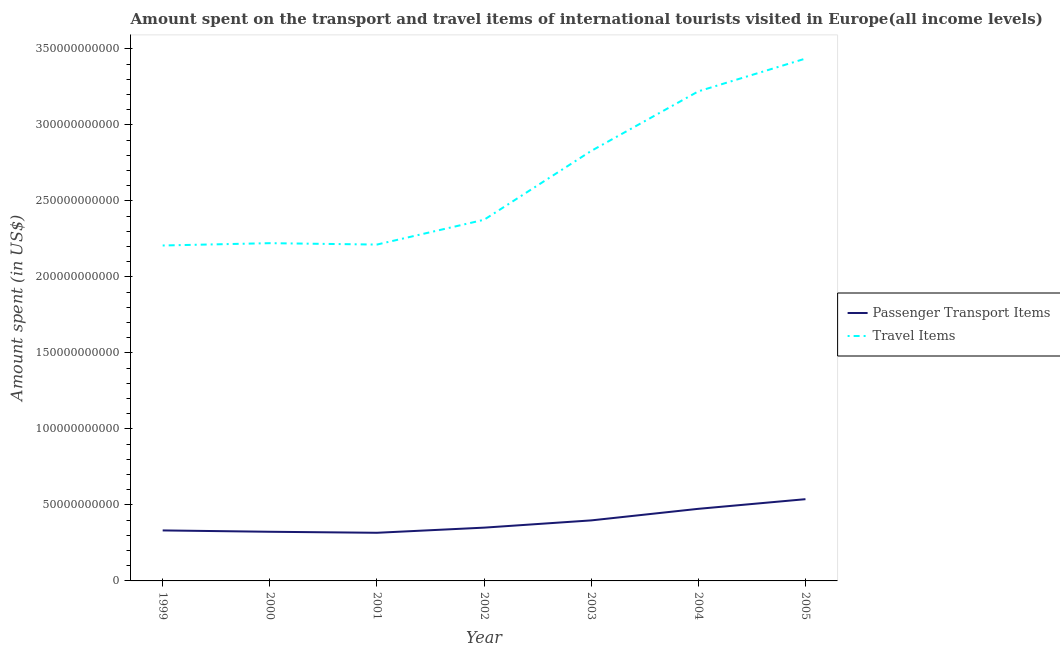Does the line corresponding to amount spent on passenger transport items intersect with the line corresponding to amount spent in travel items?
Offer a very short reply. No. What is the amount spent in travel items in 2000?
Ensure brevity in your answer.  2.22e+11. Across all years, what is the maximum amount spent in travel items?
Give a very brief answer. 3.44e+11. Across all years, what is the minimum amount spent in travel items?
Your answer should be very brief. 2.21e+11. In which year was the amount spent on passenger transport items maximum?
Your response must be concise. 2005. In which year was the amount spent on passenger transport items minimum?
Provide a short and direct response. 2001. What is the total amount spent on passenger transport items in the graph?
Make the answer very short. 2.73e+11. What is the difference between the amount spent in travel items in 2000 and that in 2005?
Offer a terse response. -1.21e+11. What is the difference between the amount spent in travel items in 2004 and the amount spent on passenger transport items in 2000?
Offer a very short reply. 2.90e+11. What is the average amount spent on passenger transport items per year?
Your answer should be very brief. 3.90e+1. In the year 2000, what is the difference between the amount spent in travel items and amount spent on passenger transport items?
Offer a terse response. 1.90e+11. What is the ratio of the amount spent in travel items in 2003 to that in 2005?
Offer a terse response. 0.82. Is the amount spent in travel items in 2001 less than that in 2003?
Offer a very short reply. Yes. Is the difference between the amount spent in travel items in 2000 and 2004 greater than the difference between the amount spent on passenger transport items in 2000 and 2004?
Offer a terse response. No. What is the difference between the highest and the second highest amount spent on passenger transport items?
Provide a succinct answer. 6.35e+09. What is the difference between the highest and the lowest amount spent in travel items?
Make the answer very short. 1.23e+11. In how many years, is the amount spent in travel items greater than the average amount spent in travel items taken over all years?
Provide a short and direct response. 3. How many years are there in the graph?
Make the answer very short. 7. Does the graph contain any zero values?
Offer a terse response. No. Where does the legend appear in the graph?
Offer a very short reply. Center right. How many legend labels are there?
Make the answer very short. 2. What is the title of the graph?
Give a very brief answer. Amount spent on the transport and travel items of international tourists visited in Europe(all income levels). What is the label or title of the X-axis?
Provide a short and direct response. Year. What is the label or title of the Y-axis?
Give a very brief answer. Amount spent (in US$). What is the Amount spent (in US$) of Passenger Transport Items in 1999?
Your response must be concise. 3.32e+1. What is the Amount spent (in US$) of Travel Items in 1999?
Keep it short and to the point. 2.21e+11. What is the Amount spent (in US$) in Passenger Transport Items in 2000?
Make the answer very short. 3.23e+1. What is the Amount spent (in US$) of Travel Items in 2000?
Provide a short and direct response. 2.22e+11. What is the Amount spent (in US$) of Passenger Transport Items in 2001?
Provide a succinct answer. 3.17e+1. What is the Amount spent (in US$) of Travel Items in 2001?
Offer a very short reply. 2.21e+11. What is the Amount spent (in US$) in Passenger Transport Items in 2002?
Provide a succinct answer. 3.50e+1. What is the Amount spent (in US$) in Travel Items in 2002?
Keep it short and to the point. 2.38e+11. What is the Amount spent (in US$) of Passenger Transport Items in 2003?
Offer a terse response. 3.98e+1. What is the Amount spent (in US$) in Travel Items in 2003?
Provide a short and direct response. 2.83e+11. What is the Amount spent (in US$) in Passenger Transport Items in 2004?
Your answer should be very brief. 4.74e+1. What is the Amount spent (in US$) in Travel Items in 2004?
Offer a very short reply. 3.22e+11. What is the Amount spent (in US$) in Passenger Transport Items in 2005?
Offer a terse response. 5.38e+1. What is the Amount spent (in US$) of Travel Items in 2005?
Your answer should be very brief. 3.44e+11. Across all years, what is the maximum Amount spent (in US$) of Passenger Transport Items?
Provide a short and direct response. 5.38e+1. Across all years, what is the maximum Amount spent (in US$) of Travel Items?
Offer a terse response. 3.44e+11. Across all years, what is the minimum Amount spent (in US$) in Passenger Transport Items?
Offer a very short reply. 3.17e+1. Across all years, what is the minimum Amount spent (in US$) of Travel Items?
Your answer should be very brief. 2.21e+11. What is the total Amount spent (in US$) of Passenger Transport Items in the graph?
Your answer should be very brief. 2.73e+11. What is the total Amount spent (in US$) in Travel Items in the graph?
Make the answer very short. 1.85e+12. What is the difference between the Amount spent (in US$) of Passenger Transport Items in 1999 and that in 2000?
Your answer should be compact. 8.83e+08. What is the difference between the Amount spent (in US$) of Travel Items in 1999 and that in 2000?
Make the answer very short. -1.52e+09. What is the difference between the Amount spent (in US$) in Passenger Transport Items in 1999 and that in 2001?
Give a very brief answer. 1.55e+09. What is the difference between the Amount spent (in US$) of Travel Items in 1999 and that in 2001?
Give a very brief answer. -6.09e+08. What is the difference between the Amount spent (in US$) in Passenger Transport Items in 1999 and that in 2002?
Your answer should be compact. -1.83e+09. What is the difference between the Amount spent (in US$) in Travel Items in 1999 and that in 2002?
Your answer should be very brief. -1.69e+1. What is the difference between the Amount spent (in US$) in Passenger Transport Items in 1999 and that in 2003?
Make the answer very short. -6.60e+09. What is the difference between the Amount spent (in US$) of Travel Items in 1999 and that in 2003?
Keep it short and to the point. -6.22e+1. What is the difference between the Amount spent (in US$) in Passenger Transport Items in 1999 and that in 2004?
Your answer should be compact. -1.42e+1. What is the difference between the Amount spent (in US$) in Travel Items in 1999 and that in 2004?
Your answer should be very brief. -1.01e+11. What is the difference between the Amount spent (in US$) of Passenger Transport Items in 1999 and that in 2005?
Your answer should be very brief. -2.06e+1. What is the difference between the Amount spent (in US$) of Travel Items in 1999 and that in 2005?
Keep it short and to the point. -1.23e+11. What is the difference between the Amount spent (in US$) in Passenger Transport Items in 2000 and that in 2001?
Provide a short and direct response. 6.68e+08. What is the difference between the Amount spent (in US$) in Travel Items in 2000 and that in 2001?
Offer a very short reply. 9.16e+08. What is the difference between the Amount spent (in US$) of Passenger Transport Items in 2000 and that in 2002?
Keep it short and to the point. -2.71e+09. What is the difference between the Amount spent (in US$) of Travel Items in 2000 and that in 2002?
Ensure brevity in your answer.  -1.54e+1. What is the difference between the Amount spent (in US$) in Passenger Transport Items in 2000 and that in 2003?
Offer a terse response. -7.48e+09. What is the difference between the Amount spent (in US$) of Travel Items in 2000 and that in 2003?
Offer a very short reply. -6.07e+1. What is the difference between the Amount spent (in US$) of Passenger Transport Items in 2000 and that in 2004?
Provide a short and direct response. -1.51e+1. What is the difference between the Amount spent (in US$) in Travel Items in 2000 and that in 2004?
Offer a very short reply. -9.99e+1. What is the difference between the Amount spent (in US$) of Passenger Transport Items in 2000 and that in 2005?
Ensure brevity in your answer.  -2.14e+1. What is the difference between the Amount spent (in US$) of Travel Items in 2000 and that in 2005?
Your response must be concise. -1.21e+11. What is the difference between the Amount spent (in US$) of Passenger Transport Items in 2001 and that in 2002?
Provide a succinct answer. -3.38e+09. What is the difference between the Amount spent (in US$) in Travel Items in 2001 and that in 2002?
Your response must be concise. -1.63e+1. What is the difference between the Amount spent (in US$) of Passenger Transport Items in 2001 and that in 2003?
Ensure brevity in your answer.  -8.15e+09. What is the difference between the Amount spent (in US$) in Travel Items in 2001 and that in 2003?
Your response must be concise. -6.16e+1. What is the difference between the Amount spent (in US$) in Passenger Transport Items in 2001 and that in 2004?
Ensure brevity in your answer.  -1.58e+1. What is the difference between the Amount spent (in US$) in Travel Items in 2001 and that in 2004?
Give a very brief answer. -1.01e+11. What is the difference between the Amount spent (in US$) of Passenger Transport Items in 2001 and that in 2005?
Ensure brevity in your answer.  -2.21e+1. What is the difference between the Amount spent (in US$) of Travel Items in 2001 and that in 2005?
Offer a very short reply. -1.22e+11. What is the difference between the Amount spent (in US$) of Passenger Transport Items in 2002 and that in 2003?
Your answer should be compact. -4.77e+09. What is the difference between the Amount spent (in US$) in Travel Items in 2002 and that in 2003?
Give a very brief answer. -4.53e+1. What is the difference between the Amount spent (in US$) of Passenger Transport Items in 2002 and that in 2004?
Keep it short and to the point. -1.24e+1. What is the difference between the Amount spent (in US$) of Travel Items in 2002 and that in 2004?
Offer a terse response. -8.45e+1. What is the difference between the Amount spent (in US$) of Passenger Transport Items in 2002 and that in 2005?
Offer a terse response. -1.87e+1. What is the difference between the Amount spent (in US$) of Travel Items in 2002 and that in 2005?
Ensure brevity in your answer.  -1.06e+11. What is the difference between the Amount spent (in US$) in Passenger Transport Items in 2003 and that in 2004?
Offer a very short reply. -7.61e+09. What is the difference between the Amount spent (in US$) in Travel Items in 2003 and that in 2004?
Make the answer very short. -3.92e+1. What is the difference between the Amount spent (in US$) in Passenger Transport Items in 2003 and that in 2005?
Provide a short and direct response. -1.40e+1. What is the difference between the Amount spent (in US$) in Travel Items in 2003 and that in 2005?
Offer a very short reply. -6.07e+1. What is the difference between the Amount spent (in US$) in Passenger Transport Items in 2004 and that in 2005?
Provide a short and direct response. -6.35e+09. What is the difference between the Amount spent (in US$) of Travel Items in 2004 and that in 2005?
Your answer should be compact. -2.16e+1. What is the difference between the Amount spent (in US$) of Passenger Transport Items in 1999 and the Amount spent (in US$) of Travel Items in 2000?
Your answer should be very brief. -1.89e+11. What is the difference between the Amount spent (in US$) of Passenger Transport Items in 1999 and the Amount spent (in US$) of Travel Items in 2001?
Your response must be concise. -1.88e+11. What is the difference between the Amount spent (in US$) of Passenger Transport Items in 1999 and the Amount spent (in US$) of Travel Items in 2002?
Your answer should be very brief. -2.04e+11. What is the difference between the Amount spent (in US$) of Passenger Transport Items in 1999 and the Amount spent (in US$) of Travel Items in 2003?
Keep it short and to the point. -2.50e+11. What is the difference between the Amount spent (in US$) in Passenger Transport Items in 1999 and the Amount spent (in US$) in Travel Items in 2004?
Keep it short and to the point. -2.89e+11. What is the difference between the Amount spent (in US$) in Passenger Transport Items in 1999 and the Amount spent (in US$) in Travel Items in 2005?
Make the answer very short. -3.10e+11. What is the difference between the Amount spent (in US$) in Passenger Transport Items in 2000 and the Amount spent (in US$) in Travel Items in 2001?
Give a very brief answer. -1.89e+11. What is the difference between the Amount spent (in US$) in Passenger Transport Items in 2000 and the Amount spent (in US$) in Travel Items in 2002?
Your answer should be compact. -2.05e+11. What is the difference between the Amount spent (in US$) in Passenger Transport Items in 2000 and the Amount spent (in US$) in Travel Items in 2003?
Your answer should be compact. -2.51e+11. What is the difference between the Amount spent (in US$) in Passenger Transport Items in 2000 and the Amount spent (in US$) in Travel Items in 2004?
Your answer should be compact. -2.90e+11. What is the difference between the Amount spent (in US$) of Passenger Transport Items in 2000 and the Amount spent (in US$) of Travel Items in 2005?
Your response must be concise. -3.11e+11. What is the difference between the Amount spent (in US$) of Passenger Transport Items in 2001 and the Amount spent (in US$) of Travel Items in 2002?
Your response must be concise. -2.06e+11. What is the difference between the Amount spent (in US$) in Passenger Transport Items in 2001 and the Amount spent (in US$) in Travel Items in 2003?
Keep it short and to the point. -2.51e+11. What is the difference between the Amount spent (in US$) of Passenger Transport Items in 2001 and the Amount spent (in US$) of Travel Items in 2004?
Provide a short and direct response. -2.90e+11. What is the difference between the Amount spent (in US$) in Passenger Transport Items in 2001 and the Amount spent (in US$) in Travel Items in 2005?
Make the answer very short. -3.12e+11. What is the difference between the Amount spent (in US$) in Passenger Transport Items in 2002 and the Amount spent (in US$) in Travel Items in 2003?
Ensure brevity in your answer.  -2.48e+11. What is the difference between the Amount spent (in US$) of Passenger Transport Items in 2002 and the Amount spent (in US$) of Travel Items in 2004?
Provide a short and direct response. -2.87e+11. What is the difference between the Amount spent (in US$) of Passenger Transport Items in 2002 and the Amount spent (in US$) of Travel Items in 2005?
Your response must be concise. -3.09e+11. What is the difference between the Amount spent (in US$) of Passenger Transport Items in 2003 and the Amount spent (in US$) of Travel Items in 2004?
Make the answer very short. -2.82e+11. What is the difference between the Amount spent (in US$) of Passenger Transport Items in 2003 and the Amount spent (in US$) of Travel Items in 2005?
Your response must be concise. -3.04e+11. What is the difference between the Amount spent (in US$) of Passenger Transport Items in 2004 and the Amount spent (in US$) of Travel Items in 2005?
Offer a very short reply. -2.96e+11. What is the average Amount spent (in US$) in Passenger Transport Items per year?
Ensure brevity in your answer.  3.90e+1. What is the average Amount spent (in US$) in Travel Items per year?
Provide a short and direct response. 2.64e+11. In the year 1999, what is the difference between the Amount spent (in US$) of Passenger Transport Items and Amount spent (in US$) of Travel Items?
Offer a terse response. -1.87e+11. In the year 2000, what is the difference between the Amount spent (in US$) of Passenger Transport Items and Amount spent (in US$) of Travel Items?
Provide a short and direct response. -1.90e+11. In the year 2001, what is the difference between the Amount spent (in US$) of Passenger Transport Items and Amount spent (in US$) of Travel Items?
Your answer should be very brief. -1.90e+11. In the year 2002, what is the difference between the Amount spent (in US$) in Passenger Transport Items and Amount spent (in US$) in Travel Items?
Provide a succinct answer. -2.03e+11. In the year 2003, what is the difference between the Amount spent (in US$) of Passenger Transport Items and Amount spent (in US$) of Travel Items?
Keep it short and to the point. -2.43e+11. In the year 2004, what is the difference between the Amount spent (in US$) in Passenger Transport Items and Amount spent (in US$) in Travel Items?
Keep it short and to the point. -2.75e+11. In the year 2005, what is the difference between the Amount spent (in US$) of Passenger Transport Items and Amount spent (in US$) of Travel Items?
Provide a short and direct response. -2.90e+11. What is the ratio of the Amount spent (in US$) of Passenger Transport Items in 1999 to that in 2000?
Offer a terse response. 1.03. What is the ratio of the Amount spent (in US$) of Passenger Transport Items in 1999 to that in 2001?
Offer a very short reply. 1.05. What is the ratio of the Amount spent (in US$) in Passenger Transport Items in 1999 to that in 2002?
Ensure brevity in your answer.  0.95. What is the ratio of the Amount spent (in US$) of Travel Items in 1999 to that in 2002?
Your response must be concise. 0.93. What is the ratio of the Amount spent (in US$) in Passenger Transport Items in 1999 to that in 2003?
Your answer should be very brief. 0.83. What is the ratio of the Amount spent (in US$) of Travel Items in 1999 to that in 2003?
Give a very brief answer. 0.78. What is the ratio of the Amount spent (in US$) in Passenger Transport Items in 1999 to that in 2004?
Make the answer very short. 0.7. What is the ratio of the Amount spent (in US$) of Travel Items in 1999 to that in 2004?
Your response must be concise. 0.69. What is the ratio of the Amount spent (in US$) of Passenger Transport Items in 1999 to that in 2005?
Your answer should be compact. 0.62. What is the ratio of the Amount spent (in US$) of Travel Items in 1999 to that in 2005?
Your response must be concise. 0.64. What is the ratio of the Amount spent (in US$) of Passenger Transport Items in 2000 to that in 2001?
Offer a very short reply. 1.02. What is the ratio of the Amount spent (in US$) in Travel Items in 2000 to that in 2001?
Make the answer very short. 1. What is the ratio of the Amount spent (in US$) in Passenger Transport Items in 2000 to that in 2002?
Your answer should be compact. 0.92. What is the ratio of the Amount spent (in US$) of Travel Items in 2000 to that in 2002?
Your response must be concise. 0.94. What is the ratio of the Amount spent (in US$) of Passenger Transport Items in 2000 to that in 2003?
Keep it short and to the point. 0.81. What is the ratio of the Amount spent (in US$) in Travel Items in 2000 to that in 2003?
Ensure brevity in your answer.  0.79. What is the ratio of the Amount spent (in US$) in Passenger Transport Items in 2000 to that in 2004?
Ensure brevity in your answer.  0.68. What is the ratio of the Amount spent (in US$) in Travel Items in 2000 to that in 2004?
Your answer should be very brief. 0.69. What is the ratio of the Amount spent (in US$) of Passenger Transport Items in 2000 to that in 2005?
Keep it short and to the point. 0.6. What is the ratio of the Amount spent (in US$) of Travel Items in 2000 to that in 2005?
Make the answer very short. 0.65. What is the ratio of the Amount spent (in US$) in Passenger Transport Items in 2001 to that in 2002?
Provide a succinct answer. 0.9. What is the ratio of the Amount spent (in US$) of Travel Items in 2001 to that in 2002?
Provide a succinct answer. 0.93. What is the ratio of the Amount spent (in US$) of Passenger Transport Items in 2001 to that in 2003?
Offer a terse response. 0.8. What is the ratio of the Amount spent (in US$) in Travel Items in 2001 to that in 2003?
Keep it short and to the point. 0.78. What is the ratio of the Amount spent (in US$) of Passenger Transport Items in 2001 to that in 2004?
Provide a short and direct response. 0.67. What is the ratio of the Amount spent (in US$) in Travel Items in 2001 to that in 2004?
Keep it short and to the point. 0.69. What is the ratio of the Amount spent (in US$) of Passenger Transport Items in 2001 to that in 2005?
Your answer should be very brief. 0.59. What is the ratio of the Amount spent (in US$) in Travel Items in 2001 to that in 2005?
Make the answer very short. 0.64. What is the ratio of the Amount spent (in US$) of Passenger Transport Items in 2002 to that in 2003?
Make the answer very short. 0.88. What is the ratio of the Amount spent (in US$) of Travel Items in 2002 to that in 2003?
Your response must be concise. 0.84. What is the ratio of the Amount spent (in US$) of Passenger Transport Items in 2002 to that in 2004?
Provide a short and direct response. 0.74. What is the ratio of the Amount spent (in US$) of Travel Items in 2002 to that in 2004?
Keep it short and to the point. 0.74. What is the ratio of the Amount spent (in US$) in Passenger Transport Items in 2002 to that in 2005?
Your response must be concise. 0.65. What is the ratio of the Amount spent (in US$) in Travel Items in 2002 to that in 2005?
Make the answer very short. 0.69. What is the ratio of the Amount spent (in US$) of Passenger Transport Items in 2003 to that in 2004?
Provide a short and direct response. 0.84. What is the ratio of the Amount spent (in US$) in Travel Items in 2003 to that in 2004?
Your response must be concise. 0.88. What is the ratio of the Amount spent (in US$) in Passenger Transport Items in 2003 to that in 2005?
Provide a short and direct response. 0.74. What is the ratio of the Amount spent (in US$) in Travel Items in 2003 to that in 2005?
Your answer should be very brief. 0.82. What is the ratio of the Amount spent (in US$) of Passenger Transport Items in 2004 to that in 2005?
Your response must be concise. 0.88. What is the ratio of the Amount spent (in US$) of Travel Items in 2004 to that in 2005?
Offer a very short reply. 0.94. What is the difference between the highest and the second highest Amount spent (in US$) in Passenger Transport Items?
Keep it short and to the point. 6.35e+09. What is the difference between the highest and the second highest Amount spent (in US$) of Travel Items?
Offer a very short reply. 2.16e+1. What is the difference between the highest and the lowest Amount spent (in US$) in Passenger Transport Items?
Offer a terse response. 2.21e+1. What is the difference between the highest and the lowest Amount spent (in US$) in Travel Items?
Make the answer very short. 1.23e+11. 